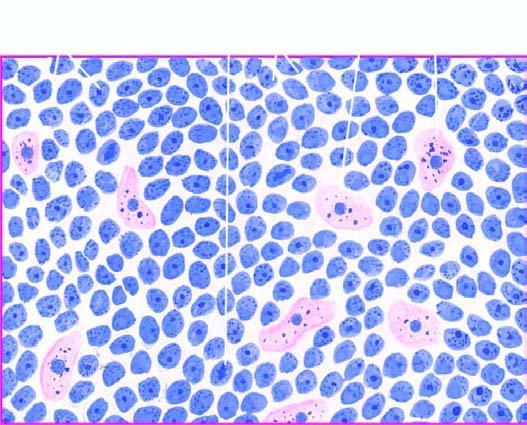what does the tumour show?
Answer the question using a single word or phrase. Uniform cells having high mitotic rate 